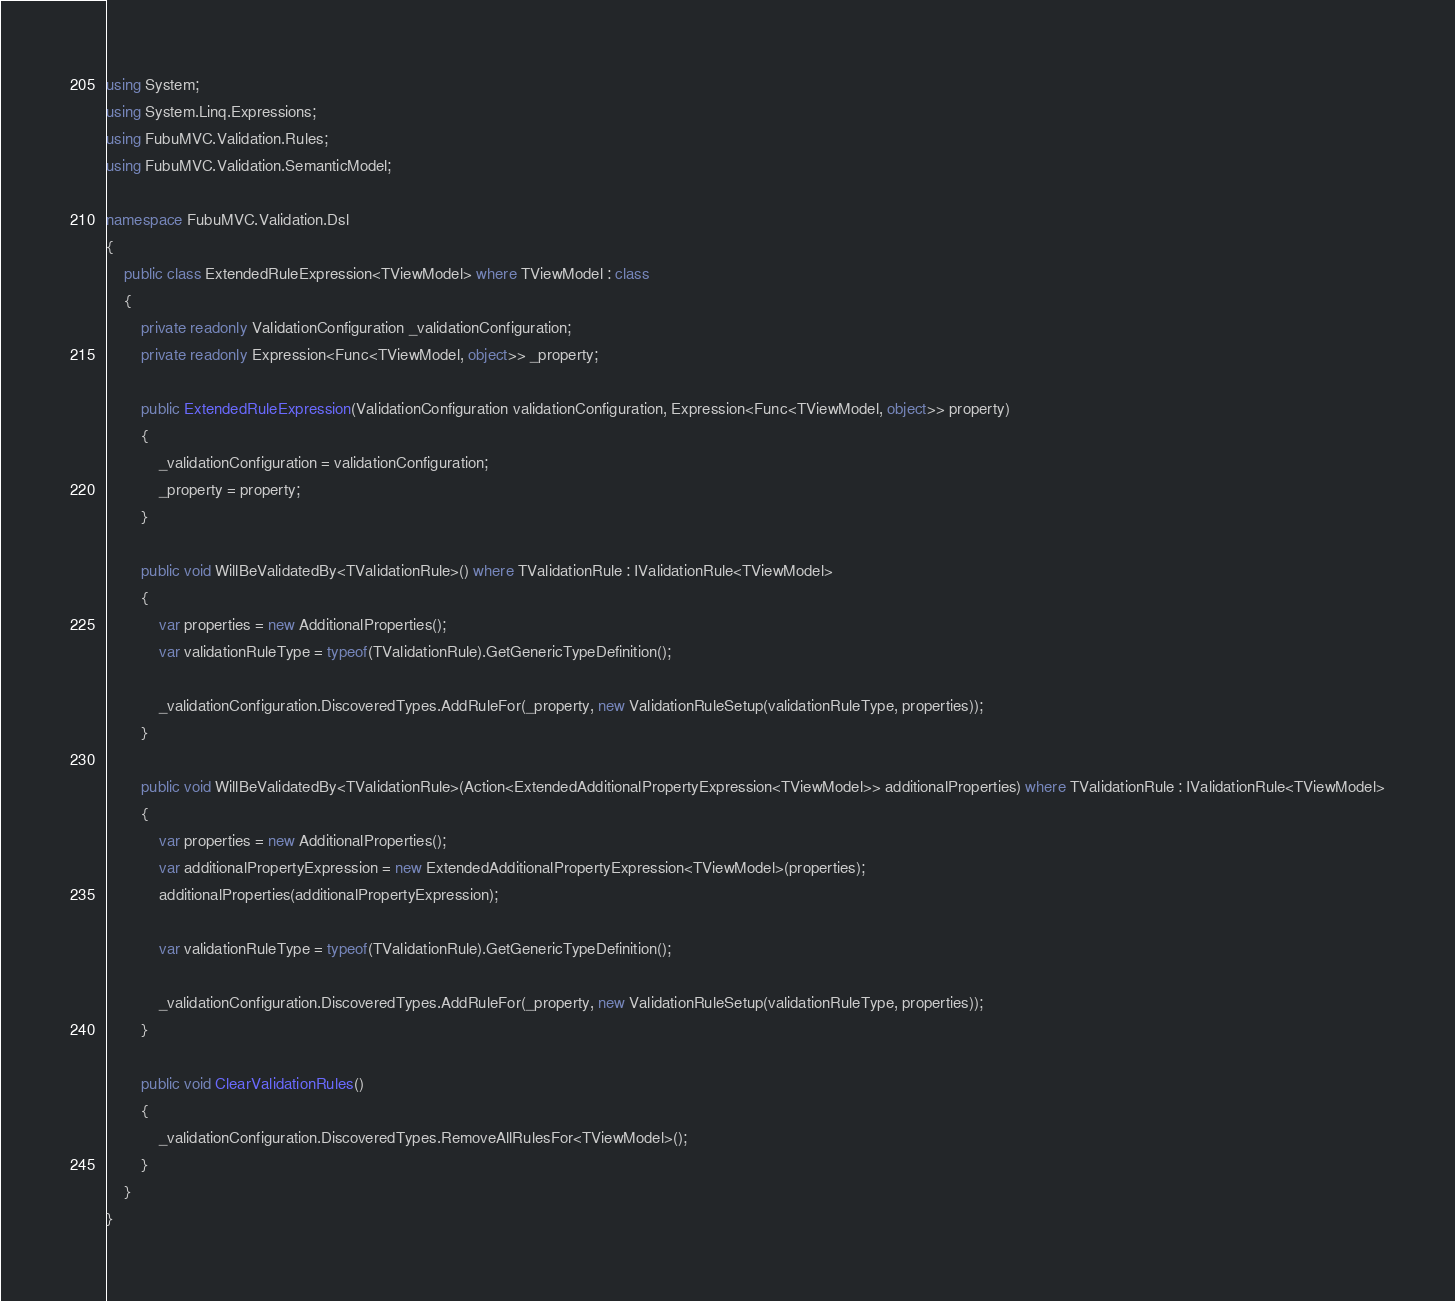Convert code to text. <code><loc_0><loc_0><loc_500><loc_500><_C#_>using System;
using System.Linq.Expressions;
using FubuMVC.Validation.Rules;
using FubuMVC.Validation.SemanticModel;

namespace FubuMVC.Validation.Dsl
{
    public class ExtendedRuleExpression<TViewModel> where TViewModel : class
    {
        private readonly ValidationConfiguration _validationConfiguration;
        private readonly Expression<Func<TViewModel, object>> _property;

        public ExtendedRuleExpression(ValidationConfiguration validationConfiguration, Expression<Func<TViewModel, object>> property)
        {
            _validationConfiguration = validationConfiguration;
            _property = property;
        }

        public void WillBeValidatedBy<TValidationRule>() where TValidationRule : IValidationRule<TViewModel>
        {
            var properties = new AdditionalProperties();
            var validationRuleType = typeof(TValidationRule).GetGenericTypeDefinition();

            _validationConfiguration.DiscoveredTypes.AddRuleFor(_property, new ValidationRuleSetup(validationRuleType, properties));
        }

        public void WillBeValidatedBy<TValidationRule>(Action<ExtendedAdditionalPropertyExpression<TViewModel>> additionalProperties) where TValidationRule : IValidationRule<TViewModel>
        {
            var properties = new AdditionalProperties();
            var additionalPropertyExpression = new ExtendedAdditionalPropertyExpression<TViewModel>(properties);
            additionalProperties(additionalPropertyExpression);

            var validationRuleType = typeof(TValidationRule).GetGenericTypeDefinition();

            _validationConfiguration.DiscoveredTypes.AddRuleFor(_property, new ValidationRuleSetup(validationRuleType, properties));
        }

        public void ClearValidationRules()
        {
            _validationConfiguration.DiscoveredTypes.RemoveAllRulesFor<TViewModel>();
        }
    }
}</code> 